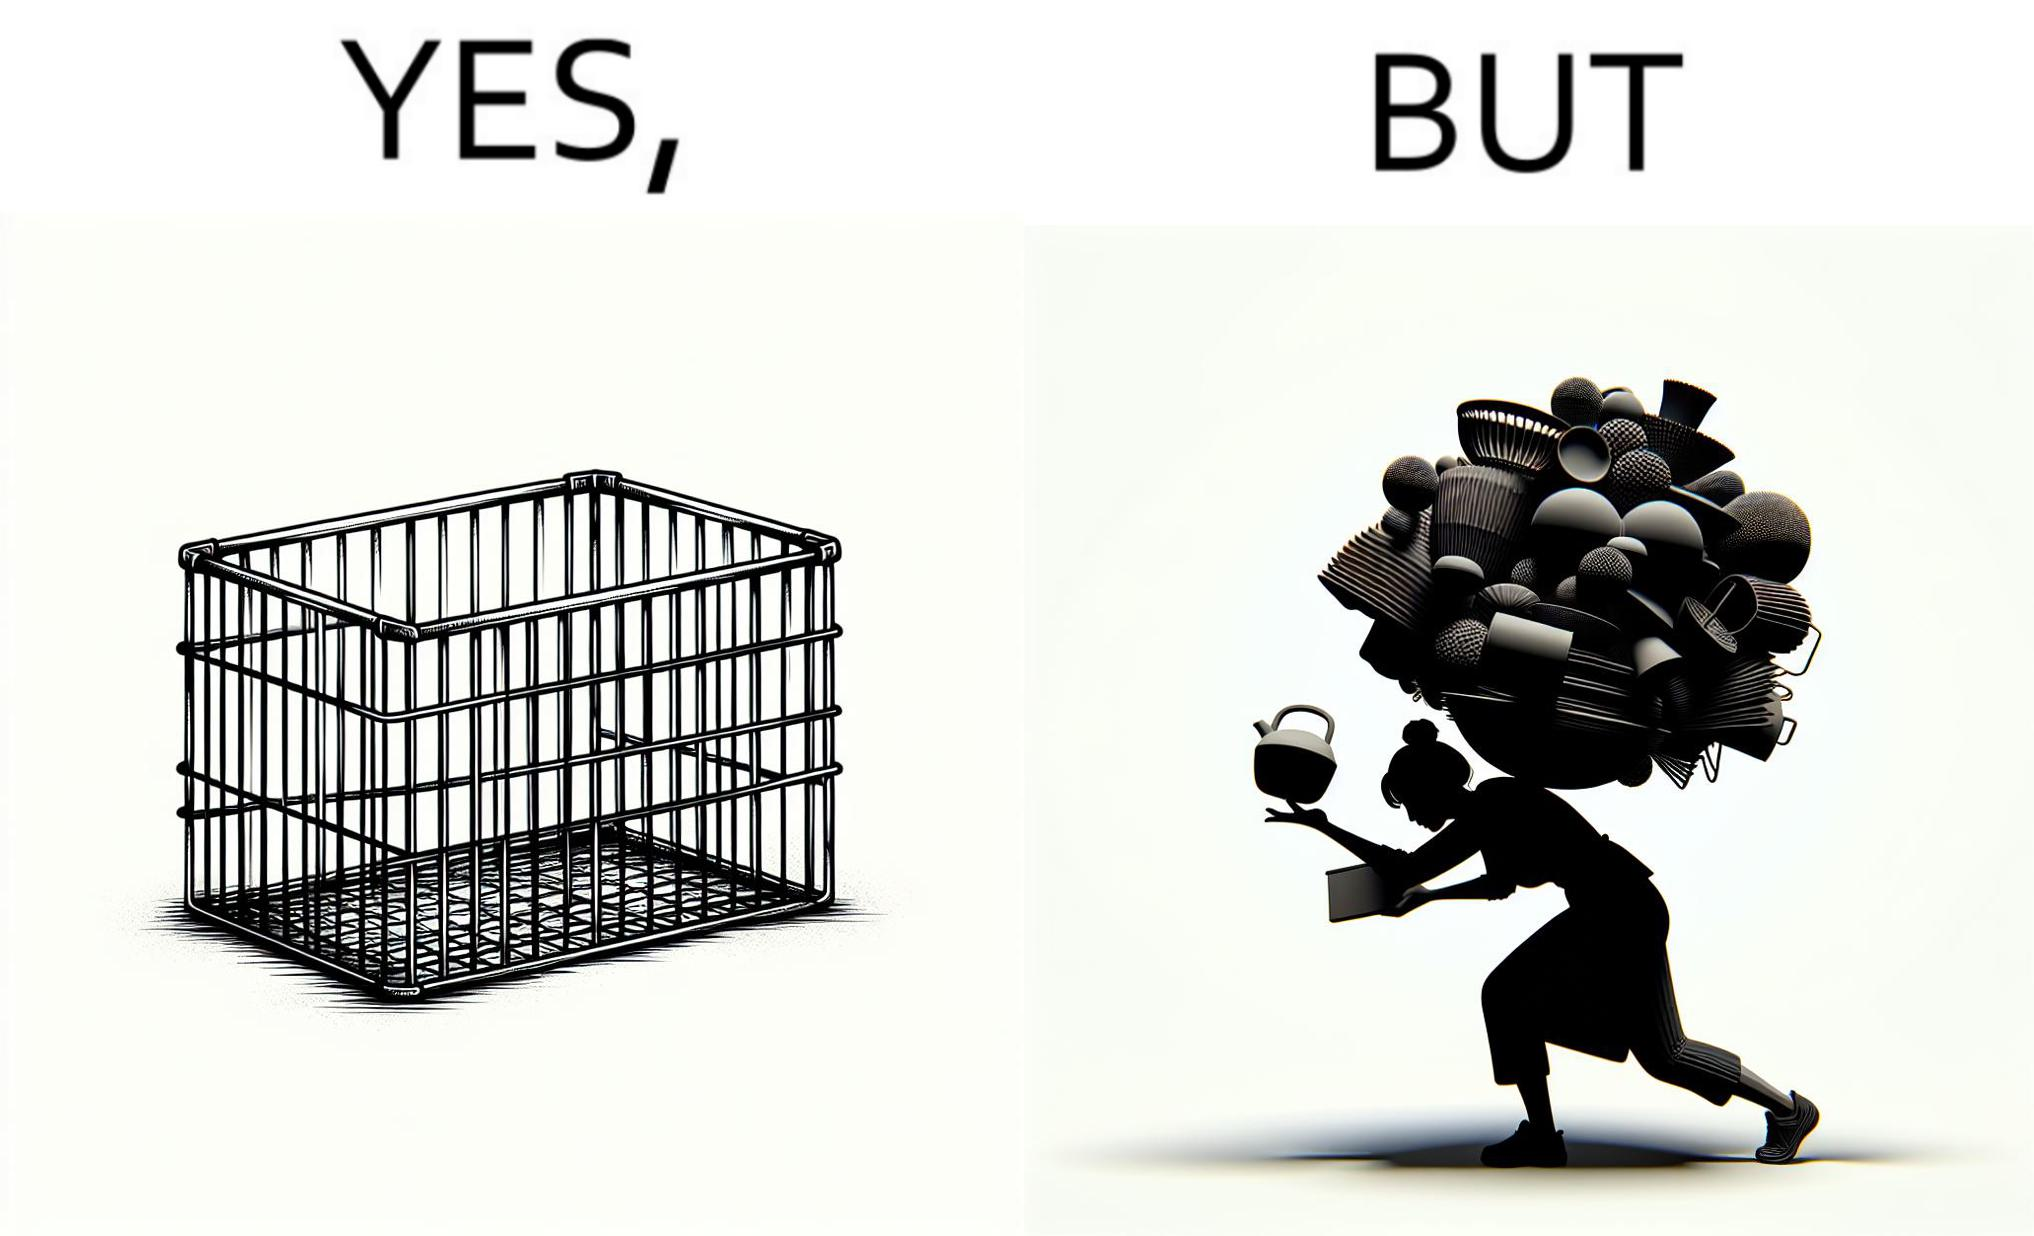Provide a description of this image. The image is ironic, because even when there are steel frame baskets are available at the supermarkets people prefer carrying the items in hand 